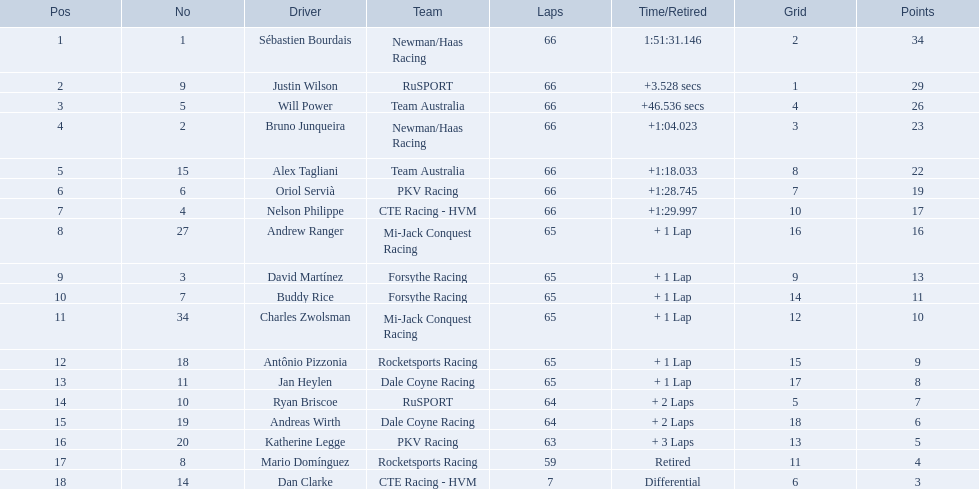Which persons obtained 29 points or more? Sébastien Bourdais, Justin Wilson. Who surpassed this score? Sébastien Bourdais. 